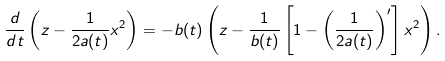<formula> <loc_0><loc_0><loc_500><loc_500>\frac { d } { d t } \left ( z - \frac { 1 } { 2 a ( t ) } x ^ { 2 } \right ) = - b ( t ) \left ( z - \frac { 1 } { b ( t ) } \left [ 1 - \left ( \frac { 1 } { 2 a ( t ) } \right ) ^ { \prime } \right ] x ^ { 2 } \right ) .</formula> 